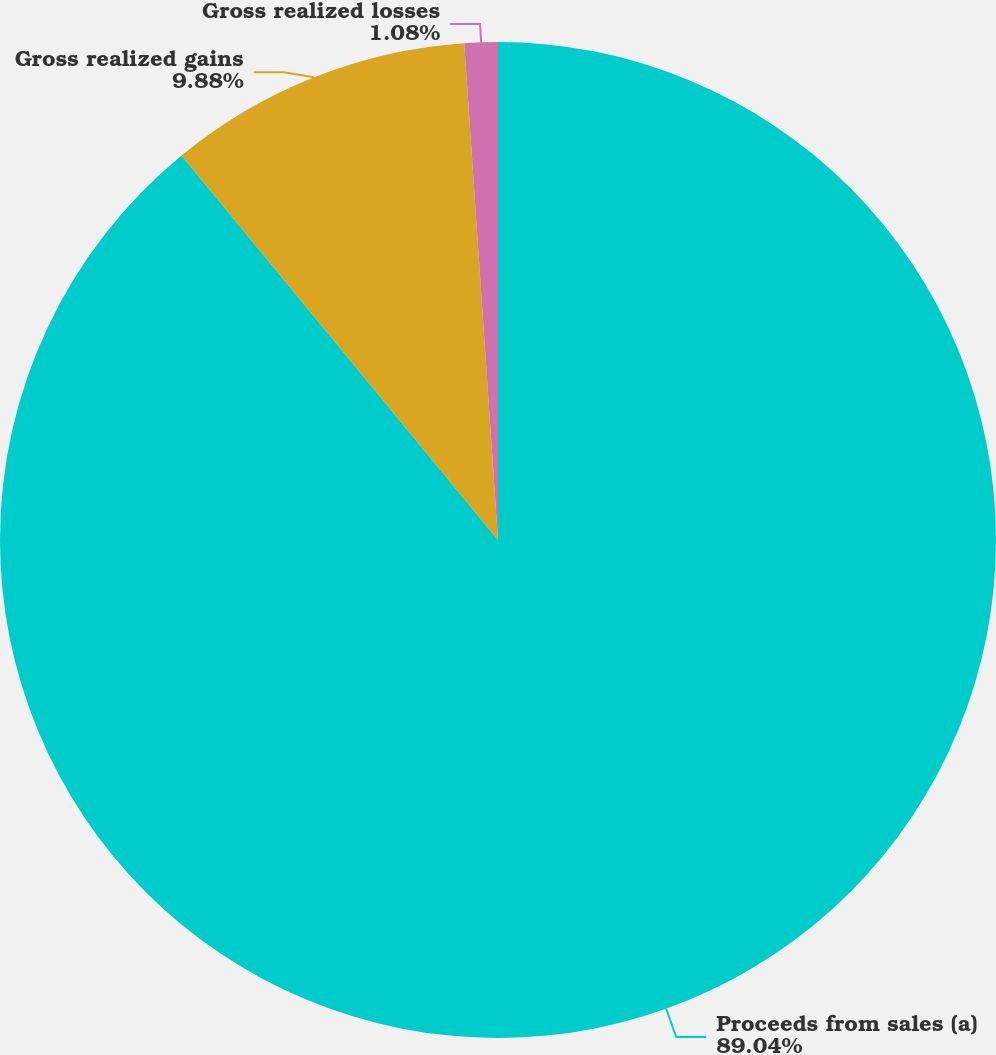<chart> <loc_0><loc_0><loc_500><loc_500><pie_chart><fcel>Proceeds from sales (a)<fcel>Gross realized gains<fcel>Gross realized losses<nl><fcel>89.04%<fcel>9.88%<fcel>1.08%<nl></chart> 